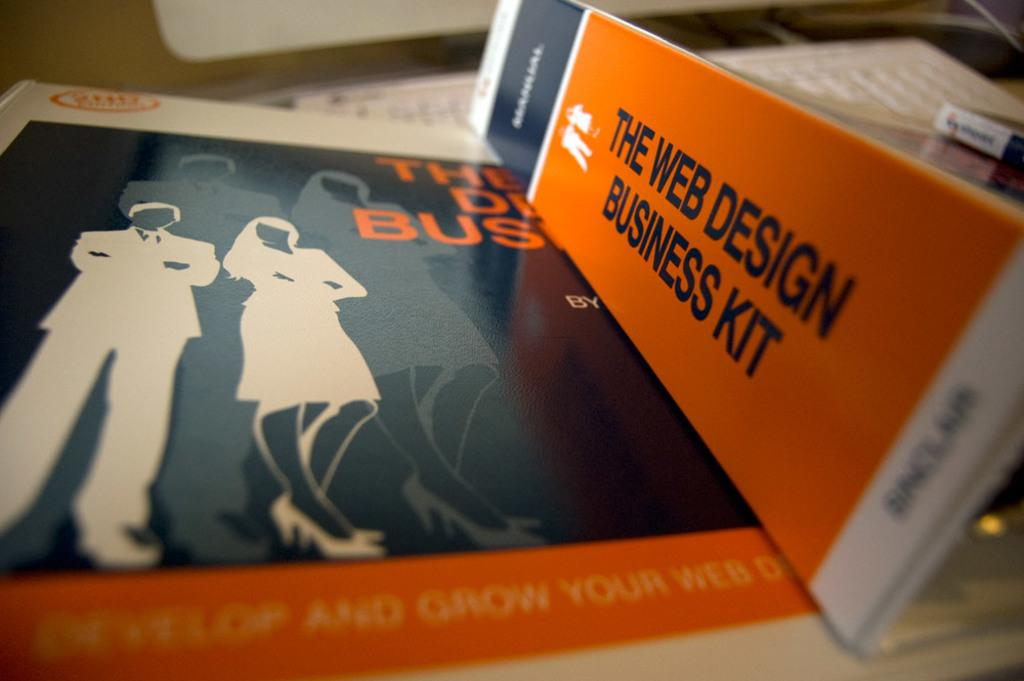<image>
Render a clear and concise summary of the photo. A book titled "The Web Design Business Kit". 